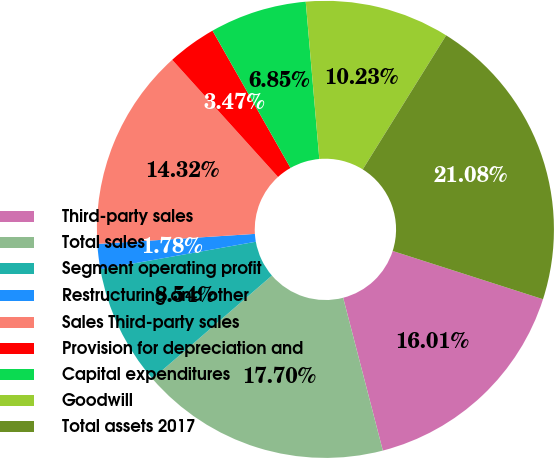Convert chart to OTSL. <chart><loc_0><loc_0><loc_500><loc_500><pie_chart><fcel>Third-party sales<fcel>Total sales<fcel>Segment operating profit<fcel>Restructuring and other<fcel>Sales Third-party sales<fcel>Provision for depreciation and<fcel>Capital expenditures<fcel>Goodwill<fcel>Total assets 2017<nl><fcel>16.01%<fcel>17.7%<fcel>8.54%<fcel>1.78%<fcel>14.32%<fcel>3.47%<fcel>6.85%<fcel>10.23%<fcel>21.08%<nl></chart> 